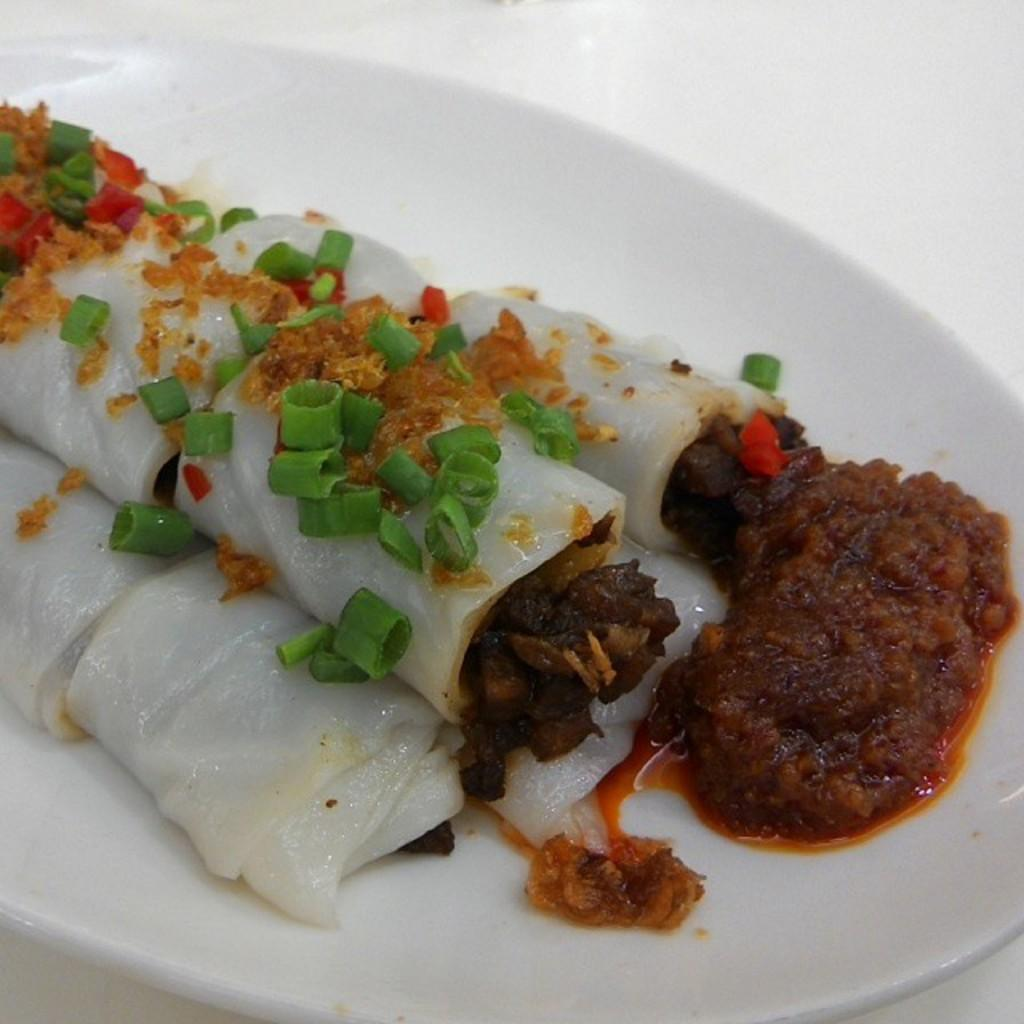What is on the plate that is visible in the image? There are food items on the plate in the image. What color is the plate? The plate is white in color. What type of food items can be seen on the plate? Chopped vegetables are present among the food items on the plate. What condiment is visible on the plate? Chutney is visible on the plate. What type of necklace is the plate wearing in the image? There is no necklace present in the image, as the plate is an inanimate object and cannot wear jewelry. 